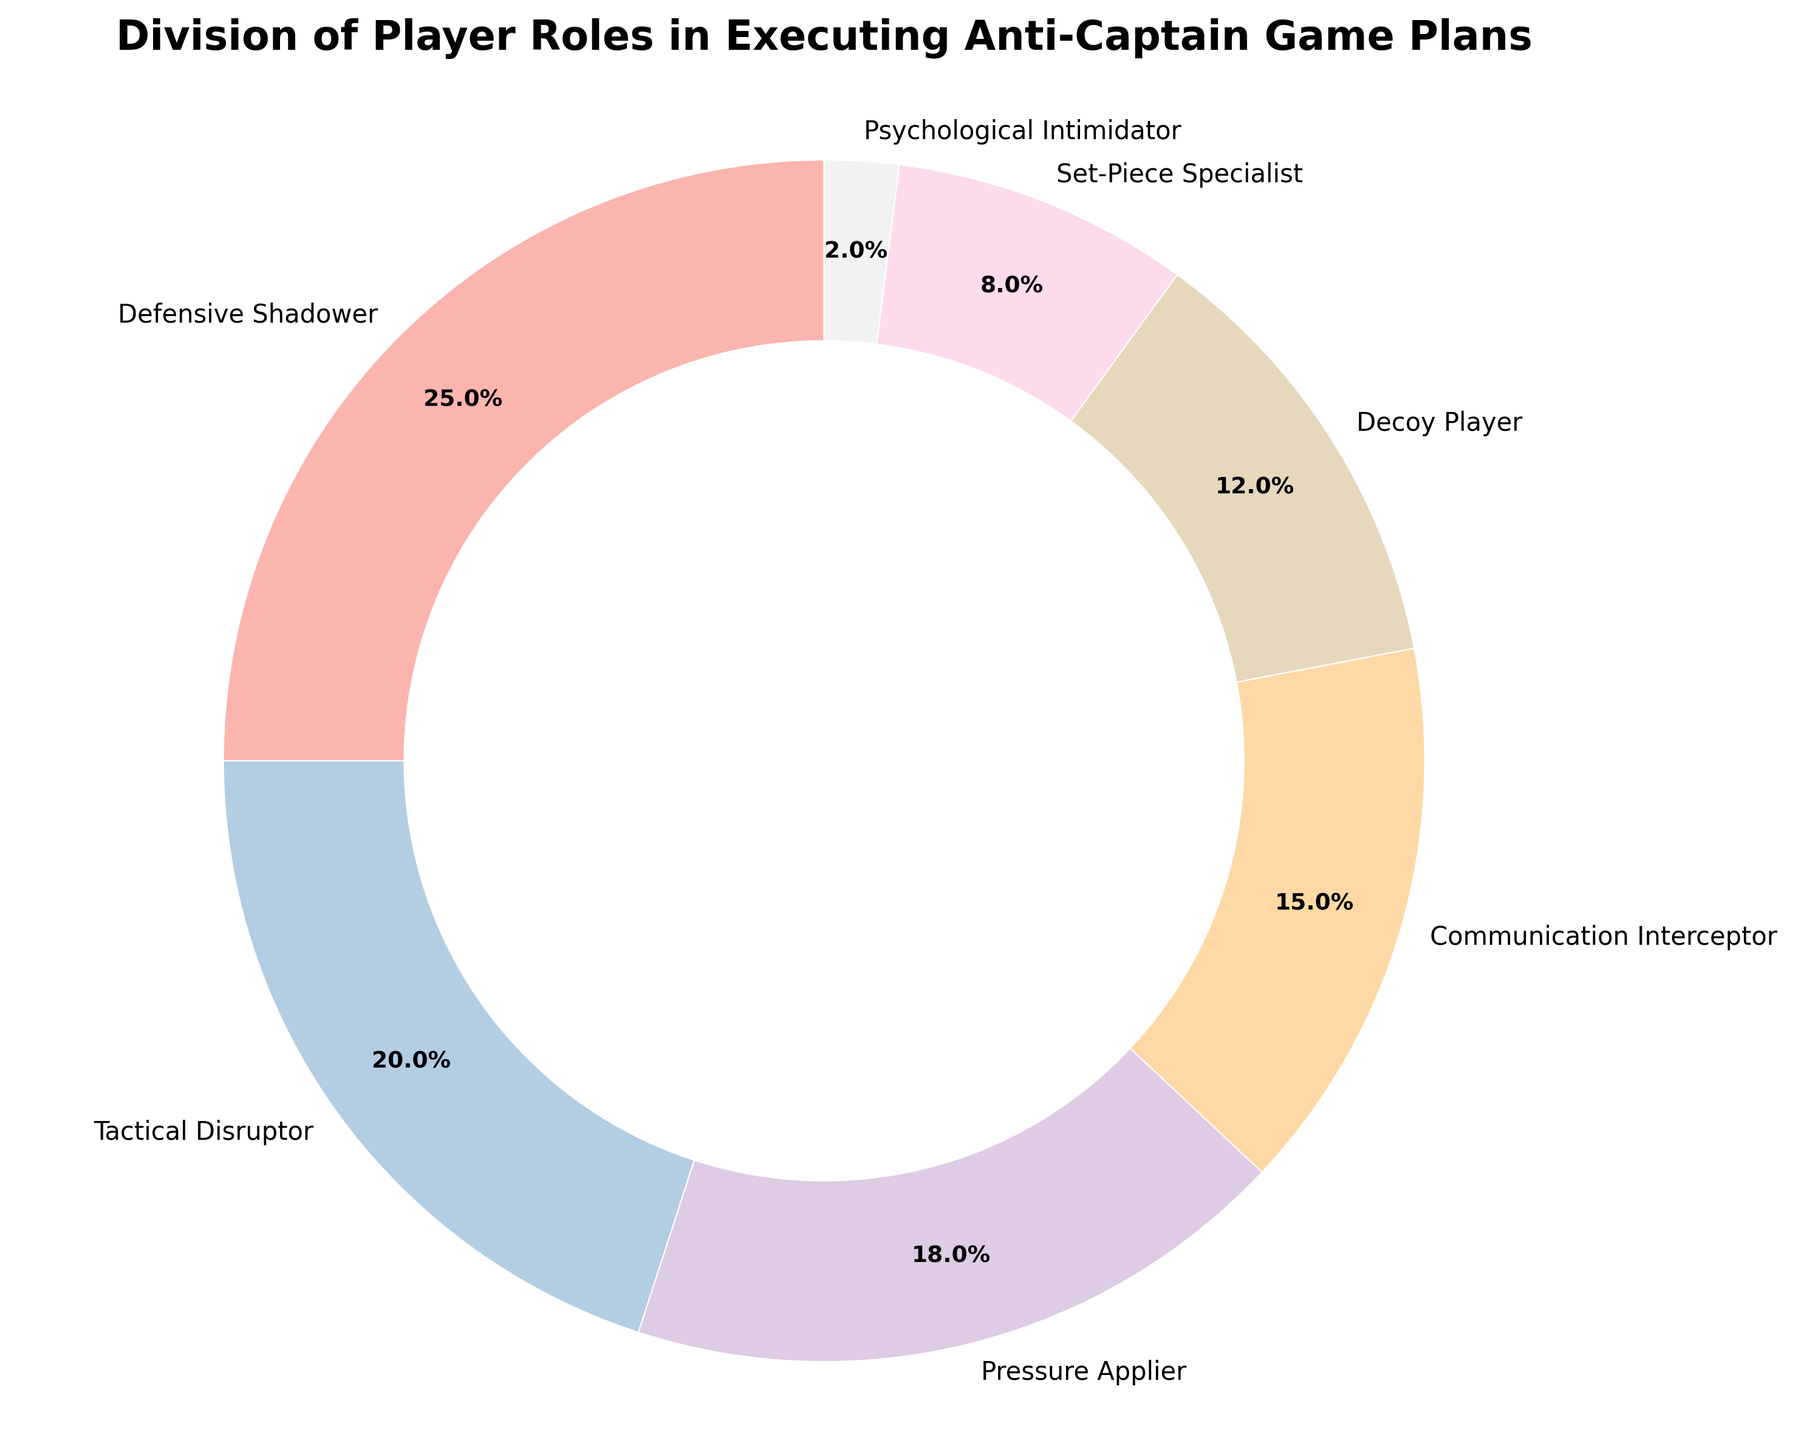What percentage of player roles involves disrupting or distracting the opposing captain directly? The roles relating to disruption and distraction are 'Tactical Disruptor', 'Decoy Player', and 'Psychological Intimidator'. Their percentages are 20%, 12%, and 2%, respectively. Adding these together: 20% + 12% + 2% = 34%
Answer: 34% Which player role has the smallest percentage? By observing the pie chart, the wedge labeled "Psychological Intimidator" is the smallest portion.
Answer: Psychological Intimidator What is the combined percentage of 'Defensive Shadower' and 'Set-Piece Specialist'? The percentages for 'Defensive Shadower' and 'Set-Piece Specialist' are 25% and 8%, respectively. Adding these together: 25% + 8% = 33%
Answer: 33% How does the percentage of 'Pressure Applier' compare to 'Communication Interceptor'? The percentage for 'Pressure Applier' is 18% and for 'Communication Interceptor' is 15%. Comparing these values, 18% is greater than 15%.
Answer: Pressure Applier is greater If you were to remove the 'Defensive Shadower', what would be the new total percentage of the remaining roles? The percentage for 'Defensive Shadower' is 25%. Subtracting this from 100% leaves 75%.
Answer: 75% What is the difference between the roles with the highest and lowest percentages? 'Defensive Shadower' has the highest percentage at 25%, and 'Psychological Intimidator' has the lowest at 2%. The difference is 25% - 2% = 23%.
Answer: 23% What role(s) collectively represent more than a third of the distribution? To represent more than a third of the distribution, the role(s) must constitute more than 33.3%. 'Defensive Shadower' is 25%, and 'Tactical Disruptor' is 20%. Collectively, they are 25% + 20% = 45%, which is more than a third.
Answer: Defensive Shadower and Tactical Disruptor Rank the roles from highest to lowest percentage. Observing the chart, the percentages in descending order are: Defensive Shadower (25%), Tactical Disruptor (20%), Pressure Applier (18%), Communication Interceptor (15%), Decoy Player (12%), Set-Piece Specialist (8%), Psychological Intimidator(2%).
Answer: Defensive Shadower, Tactical Disruptor, Pressure Applier, Communication Interceptor, Decoy Player, Set-Piece Specialist, Psychological Intimidator 